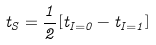<formula> <loc_0><loc_0><loc_500><loc_500>t _ { S } = \frac { 1 } { 2 } [ t _ { I = 0 } - t _ { I = 1 } ]</formula> 